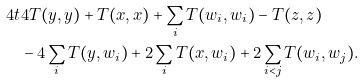Convert formula to latex. <formula><loc_0><loc_0><loc_500><loc_500>4 t & 4 T ( y , y ) + T ( x , x ) + \sum _ { i } T ( w _ { i } , w _ { i } ) - T ( z , z ) \\ & - 4 \sum _ { i } T ( y , w _ { i } ) + 2 \sum _ { i } T ( x , w _ { i } ) + 2 \sum _ { i < j } T ( w _ { i } , w _ { j } ) .</formula> 